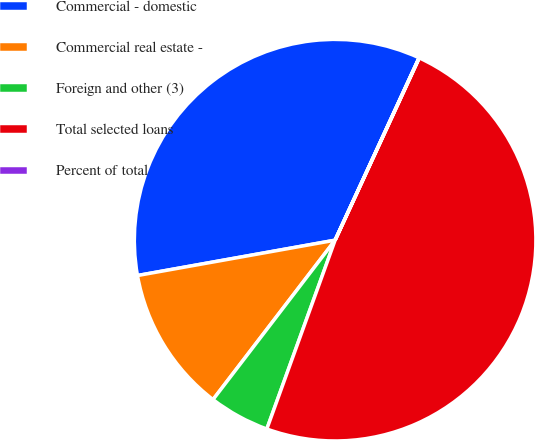<chart> <loc_0><loc_0><loc_500><loc_500><pie_chart><fcel>Commercial - domestic<fcel>Commercial real estate -<fcel>Foreign and other (3)<fcel>Total selected loans<fcel>Percent of total<nl><fcel>34.68%<fcel>11.78%<fcel>4.88%<fcel>48.64%<fcel>0.02%<nl></chart> 